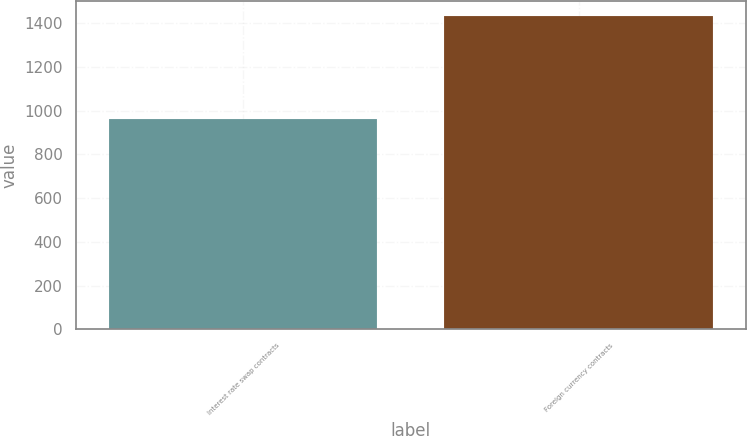Convert chart. <chart><loc_0><loc_0><loc_500><loc_500><bar_chart><fcel>Interest rate swap contracts<fcel>Foreign currency contracts<nl><fcel>959.2<fcel>1430.7<nl></chart> 